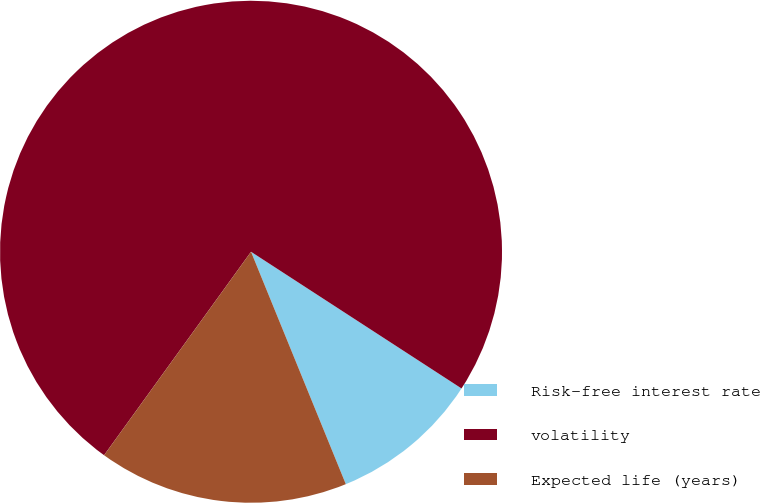Convert chart. <chart><loc_0><loc_0><loc_500><loc_500><pie_chart><fcel>Risk-free interest rate<fcel>volatility<fcel>Expected life (years)<nl><fcel>9.67%<fcel>74.21%<fcel>16.12%<nl></chart> 